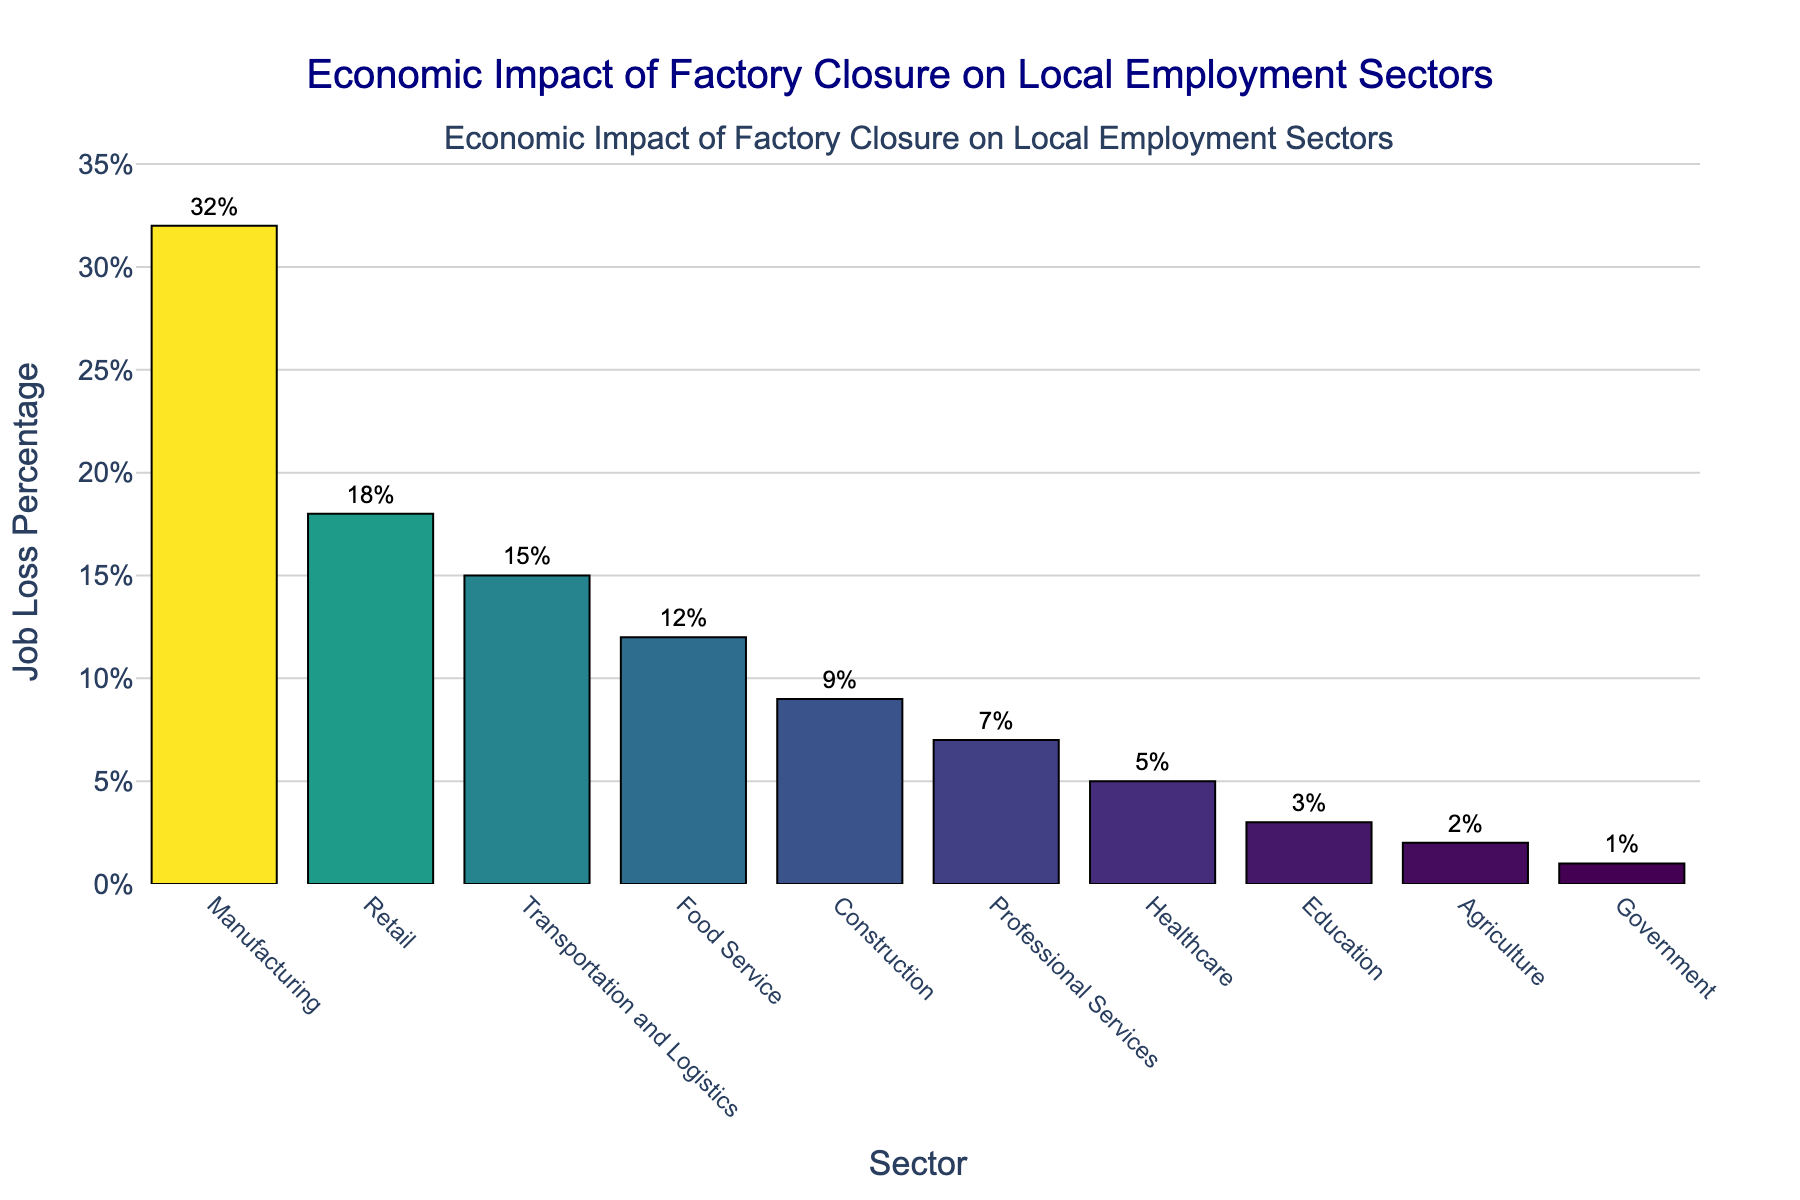Which sector experiences the highest job loss percentage? The bar chart shows the job loss percentages for various sectors. By visually identifying the highest bar, we see that Manufacturing has the largest value.
Answer: Manufacturing Which sectors have job loss percentages below 10%? The sectors with bars that do not reach the 10% mark are those with job loss percentages below 10%. These are Construction, Professional Services, Healthcare, Education, Agriculture, and Government.
Answer: Construction, Professional Services, Healthcare, Education, Agriculture, Government How much higher is the job loss percentage in Manufacturing compared to Retail? The job loss in Manufacturing is 32%, while in Retail it is 18%. To find the difference: 32% - 18% = 14%.
Answer: 14% Which sectors have a job loss percentage within 5% of each other? By comparing the bars, we identify the pairs where the difference in height between the bars is within 5%. Retail (18%) and Transportation and Logistics (15%) are within 3%. Food Service (12%) and Construction (9%) are within 3%.
Answer: Retail and Transportation and Logistics, Food Service and Construction What is the combined job loss percentage for Education, Agriculture, and Government sectors? Sum the job loss percentages for the identified sectors: Education (3%), Agriculture (2%), and Government (1%). The total is 3% + 2% + 1% = 6%.
Answer: 6% Which sector has the least job loss percentage, and by how much less is it compared to the Healthcare sector? The Healthcare sector has a 5% job loss, and the Government sector has the least with 1%. The difference is 5% - 1% = 4%.
Answer: Government, 4% What is the average job loss percentage for the top three sectors with the highest job losses? The top three sectors are Manufacturing (32%), Retail (18%), and Transportation and Logistics (15%). Average = (32% + 18% + 15%) / 3 = 65% / 3 ≈ 21.67%.
Answer: 21.67% How many sectors have a job loss percentage between 10% and 20%? By examining the bars that fall within this range: Retail (18%), Transportation and Logistics (15%), and Food Service (12%) are included. This gives three sectors.
Answer: 3 sectors What is the difference in job loss percentage between Professional Services and Agriculture? Professional Services has a job loss of 7%, and Agriculture has 2%. The difference is 7% - 2% = 5%.
Answer: 5% Is there a sector whose job loss percentage is exactly twice that of Healthcare? If so, which one? Healthcare has a job loss of 5%. We need a sector with double this, i.e., 10%. As per the chart, no sector exactly matches 10%.
Answer: No 